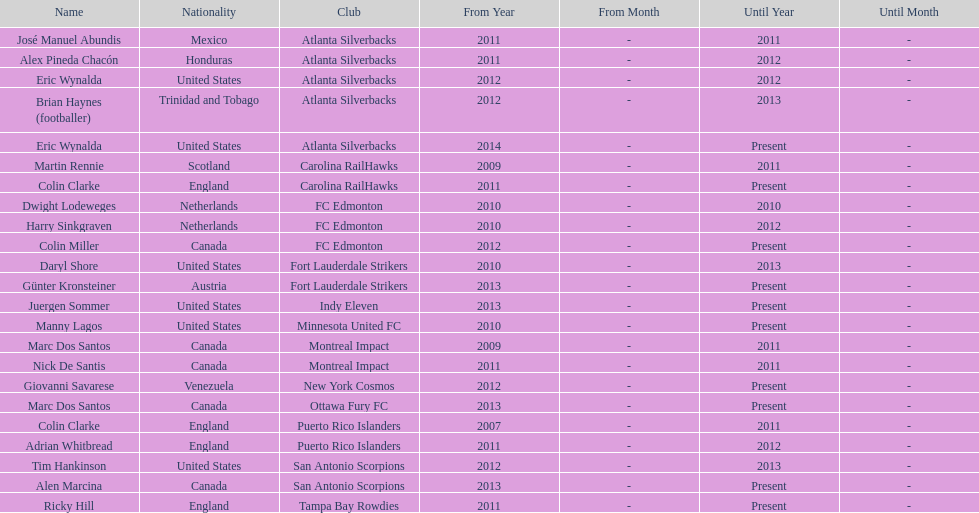How many total coaches on the list are from canada? 5. 